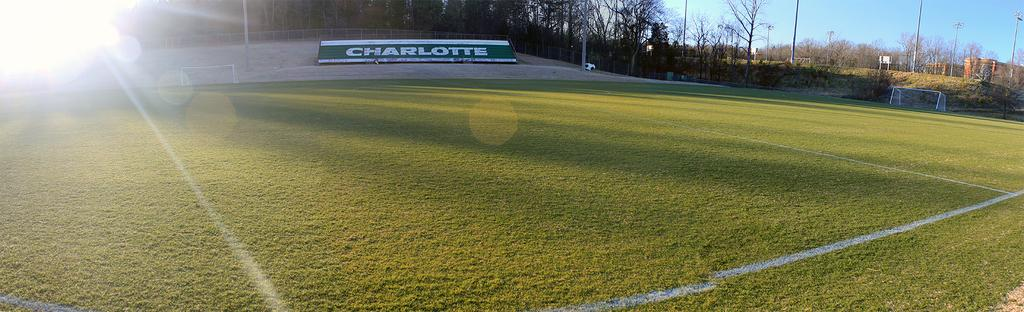What color is the border around the ground in the image? The ground has a yellow border. What type of natural elements can be seen in the image? There are trees in the image. What object is present in the image that is commonly used in sports? There is a ball in the image. What type of sports facility is depicted in the image? There is a goal court in the image. How many trees are visible in the image? There are additional trees in the image. What structures can be seen supporting the goal court or other elements in the image? There are poles in the image. What type of box is used to reward the players in the image? There is no box or reward system present in the image. How does the bit affect the performance of the players in the image? There is no mention of a bit or any equestrian activity in the image. 